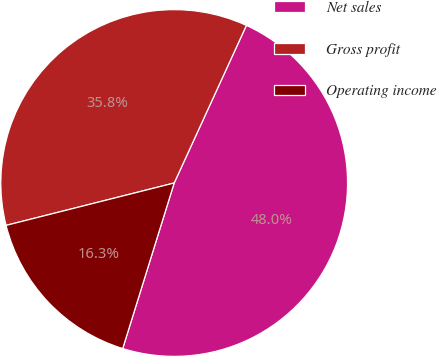<chart> <loc_0><loc_0><loc_500><loc_500><pie_chart><fcel>Net sales<fcel>Gross profit<fcel>Operating income<nl><fcel>47.96%<fcel>35.77%<fcel>16.27%<nl></chart> 